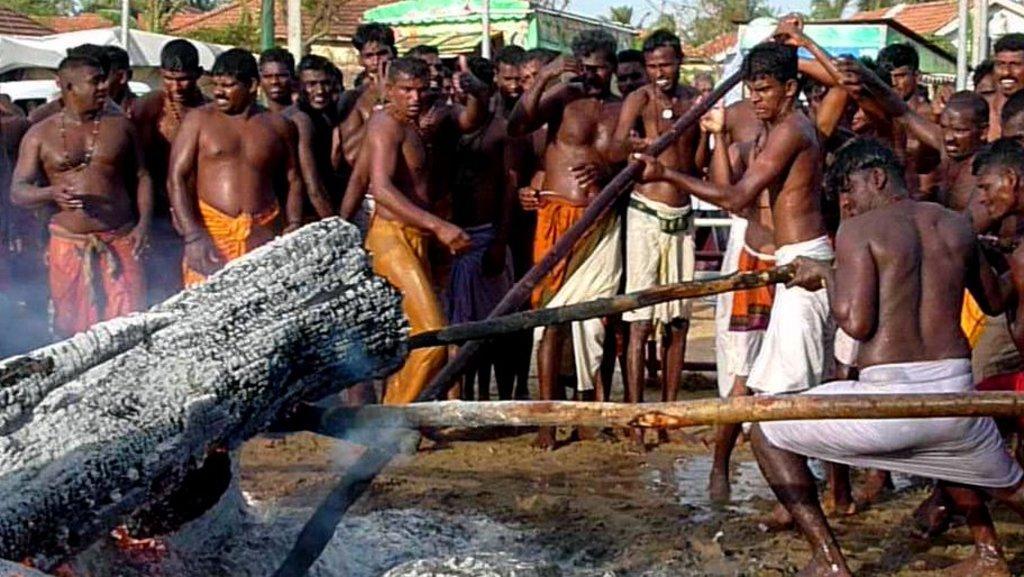Please provide a concise description of this image. In the image there are a group of people burning some objects with the help of wooden sticks and behind them there are many other people, in the background there are houses and trees. 